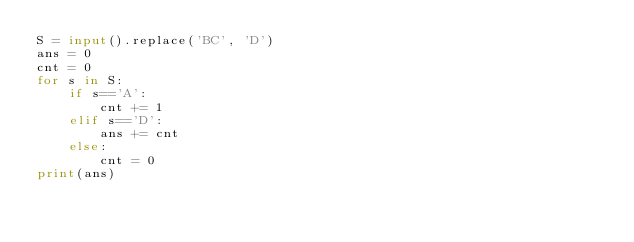<code> <loc_0><loc_0><loc_500><loc_500><_Python_>S = input().replace('BC', 'D')
ans = 0
cnt = 0
for s in S:
    if s=='A':
        cnt += 1
    elif s=='D':
        ans += cnt
    else:
        cnt = 0
print(ans)</code> 